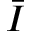Convert formula to latex. <formula><loc_0><loc_0><loc_500><loc_500>\ B a r { I }</formula> 